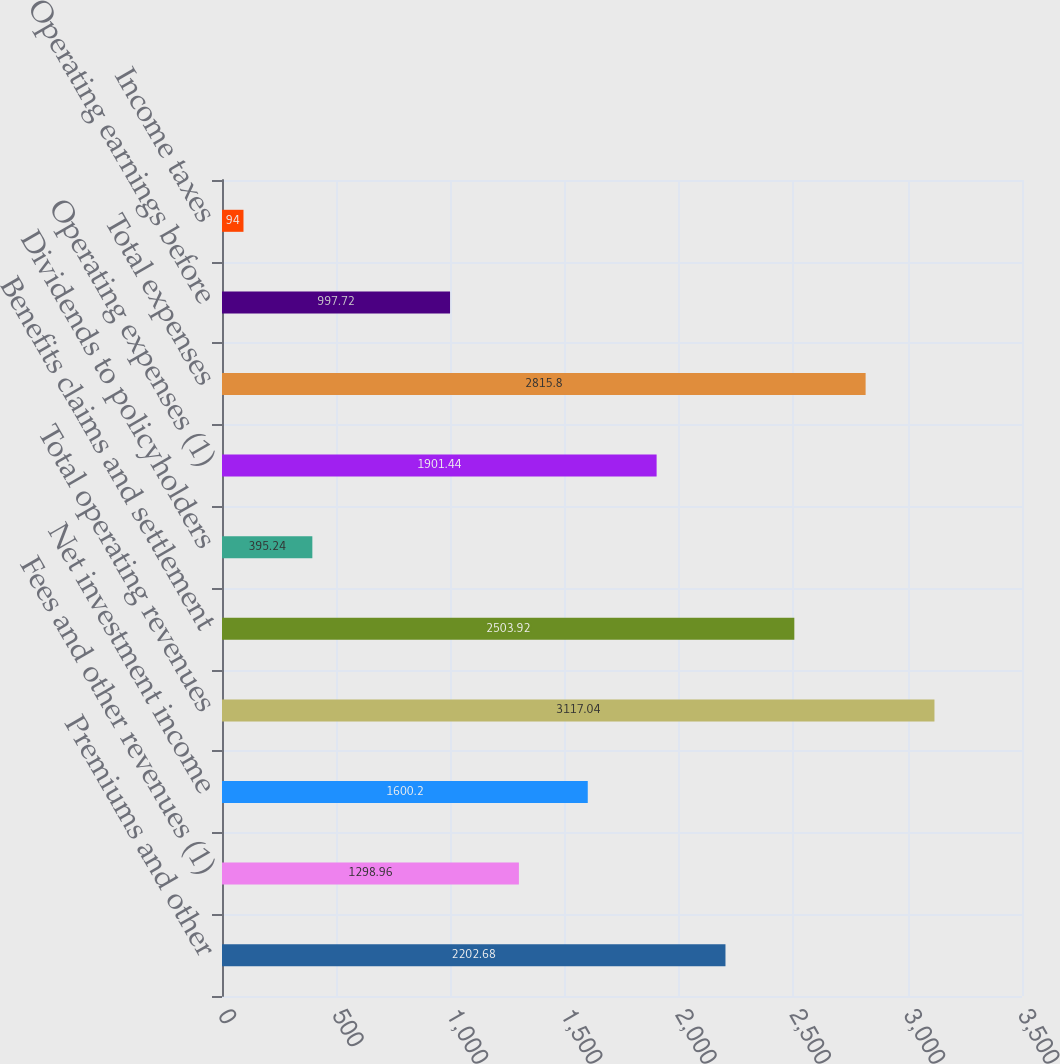Convert chart to OTSL. <chart><loc_0><loc_0><loc_500><loc_500><bar_chart><fcel>Premiums and other<fcel>Fees and other revenues (1)<fcel>Net investment income<fcel>Total operating revenues<fcel>Benefits claims and settlement<fcel>Dividends to policyholders<fcel>Operating expenses (1)<fcel>Total expenses<fcel>Operating earnings before<fcel>Income taxes<nl><fcel>2202.68<fcel>1298.96<fcel>1600.2<fcel>3117.04<fcel>2503.92<fcel>395.24<fcel>1901.44<fcel>2815.8<fcel>997.72<fcel>94<nl></chart> 